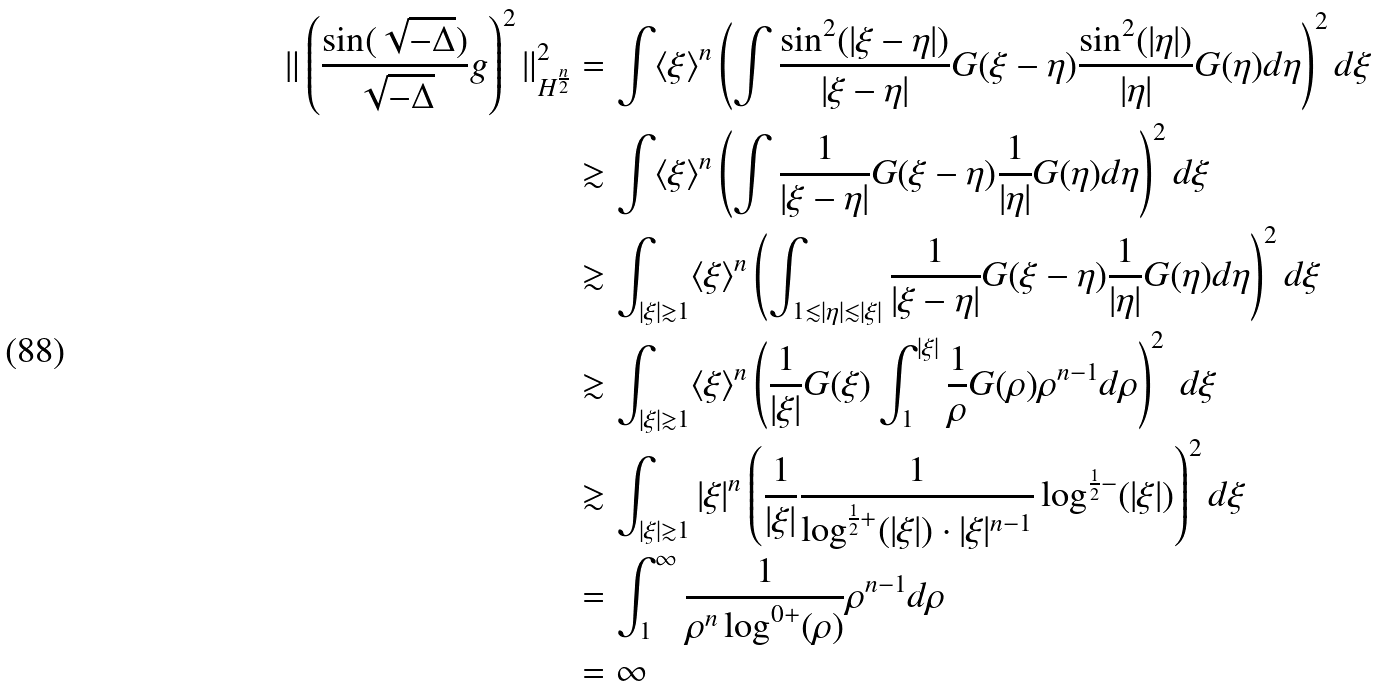Convert formula to latex. <formula><loc_0><loc_0><loc_500><loc_500>\| \left ( \frac { \sin ( \sqrt { - \Delta } ) } { \sqrt { - \Delta } } g \right ) ^ { 2 } \| ^ { 2 } _ { H ^ { \frac { n } { 2 } } } & = \int \langle \xi \rangle ^ { n } \left ( \int \frac { \sin ^ { 2 } ( | \xi - \eta | ) } { | \xi - \eta | } G ( \xi - \eta ) \frac { \sin ^ { 2 } ( | \eta | ) } { | \eta | } G ( \eta ) d \eta \right ) ^ { 2 } d \xi \\ & \gtrsim \int \langle \xi \rangle ^ { n } \left ( \int \frac { 1 } { | \xi - \eta | } G ( \xi - \eta ) \frac { 1 } { | \eta | } G ( \eta ) d \eta \right ) ^ { 2 } d \xi \\ & \gtrsim \int _ { | \xi | \gtrsim 1 } \langle \xi \rangle ^ { n } \left ( \int _ { 1 \lesssim | \eta | \lesssim | \xi | } \frac { 1 } { | \xi - \eta | } G ( \xi - \eta ) \frac { 1 } { | \eta | } G ( \eta ) d \eta \right ) ^ { 2 } d \xi \\ & \gtrsim \int _ { | \xi | \gtrsim 1 } \langle \xi \rangle ^ { n } \left ( \frac { 1 } { | \xi | } G ( \xi ) \int _ { 1 } ^ { | \xi | } \frac { 1 } { \rho } G ( \rho ) \rho ^ { n - 1 } d \rho \right ) ^ { 2 } \ d \xi \\ & \gtrsim \int _ { | \xi | \gtrsim 1 } | \xi | ^ { n } \left ( \frac { 1 } { | \xi | } \frac { 1 } { \log ^ { \frac { 1 } { 2 } + } ( | \xi | ) \cdot | \xi | ^ { n - 1 } } \log ^ { \frac { 1 } { 2 } - } ( | \xi | ) \right ) ^ { 2 } d \xi \\ & = \int _ { 1 } ^ { \infty } \frac { 1 } { \rho ^ { n } \log ^ { 0 + } ( \rho ) } \rho ^ { n - 1 } d \rho \\ & = \infty</formula> 